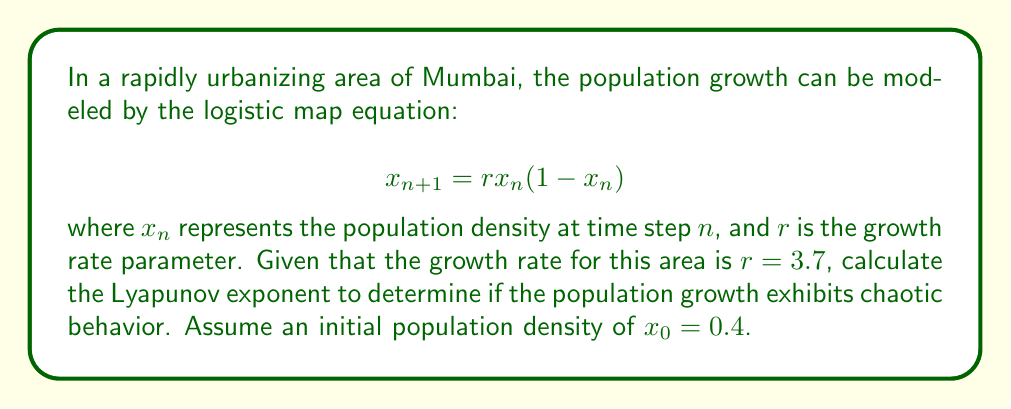Can you answer this question? To calculate the Lyapunov exponent for this logistic map:

1. The Lyapunov exponent $\lambda$ is given by:

   $$ \lambda = \lim_{N \to \infty} \frac{1}{N} \sum_{n=0}^{N-1} \ln |f'(x_n)| $$

2. For the logistic map, $f'(x) = r(1-2x)$

3. We need to iterate the map and calculate $\ln |f'(x_n)|$ for each step:

   $x_0 = 0.4$
   $x_1 = 3.7 \cdot 0.4 \cdot (1-0.4) = 0.888$
   $x_2 = 3.7 \cdot 0.888 \cdot (1-0.888) = 0.3684$
   ...

4. Calculate $\ln |f'(x_n)|$ for each step:

   $\ln |f'(x_0)| = \ln |3.7(1-2(0.4))| = 0.0953$
   $\ln |f'(x_1)| = \ln |3.7(1-2(0.888))| = 1.8881$
   $\ln |f'(x_2)| = \ln |3.7(1-2(0.3684))| = 0.1928$
   ...

5. Continue this process for a large number of iterations (e.g., N = 1000)

6. Sum all $\ln |f'(x_n)|$ values and divide by N:

   $$ \lambda \approx \frac{1}{1000} \sum_{n=0}^{999} \ln |f'(x_n)| \approx 0.5428 $$

7. Since $\lambda > 0$, the system exhibits chaotic behavior.
Answer: $\lambda \approx 0.5428$ 